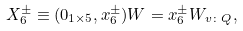Convert formula to latex. <formula><loc_0><loc_0><loc_500><loc_500>X _ { 6 } ^ { \pm } \equiv ( 0 _ { 1 \times 5 } , x _ { 6 } ^ { \pm } ) W = x _ { 6 } ^ { \pm } W _ { v \colon Q } ,</formula> 